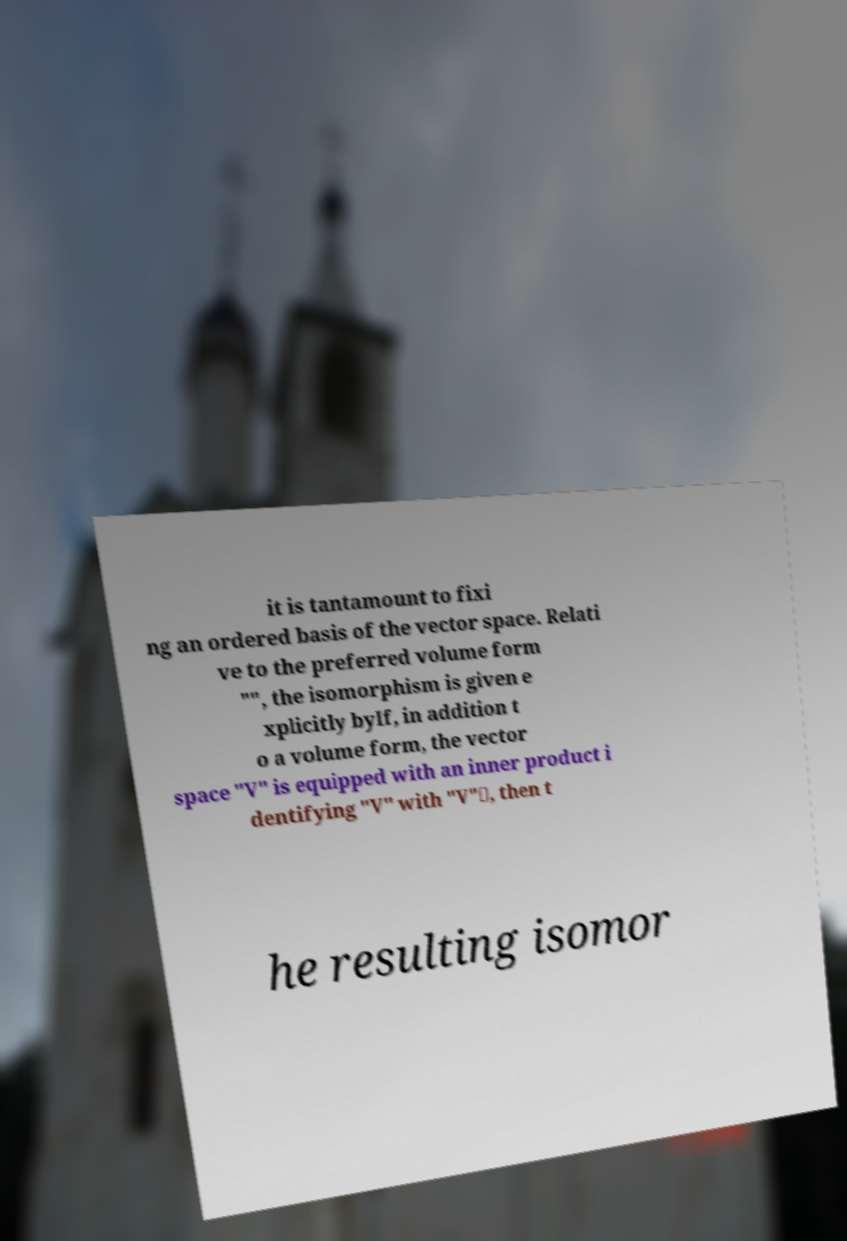Can you accurately transcribe the text from the provided image for me? it is tantamount to fixi ng an ordered basis of the vector space. Relati ve to the preferred volume form "", the isomorphism is given e xplicitly byIf, in addition t o a volume form, the vector space "V" is equipped with an inner product i dentifying "V" with "V"∗, then t he resulting isomor 